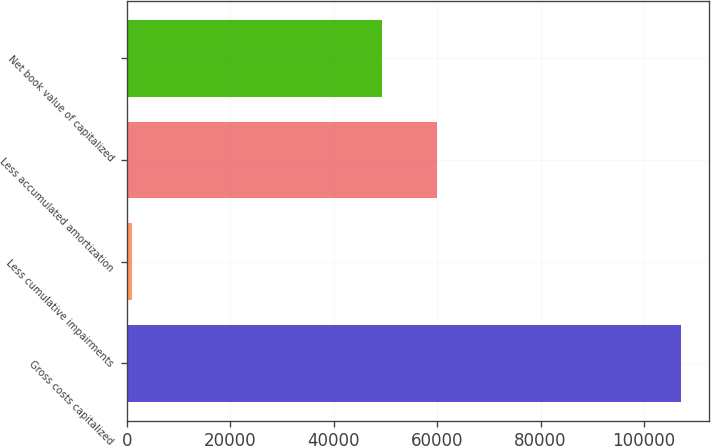Convert chart. <chart><loc_0><loc_0><loc_500><loc_500><bar_chart><fcel>Gross costs capitalized<fcel>Less cumulative impairments<fcel>Less accumulated amortization<fcel>Net book value of capitalized<nl><fcel>107125<fcel>1050<fcel>59904.5<fcel>49297<nl></chart> 